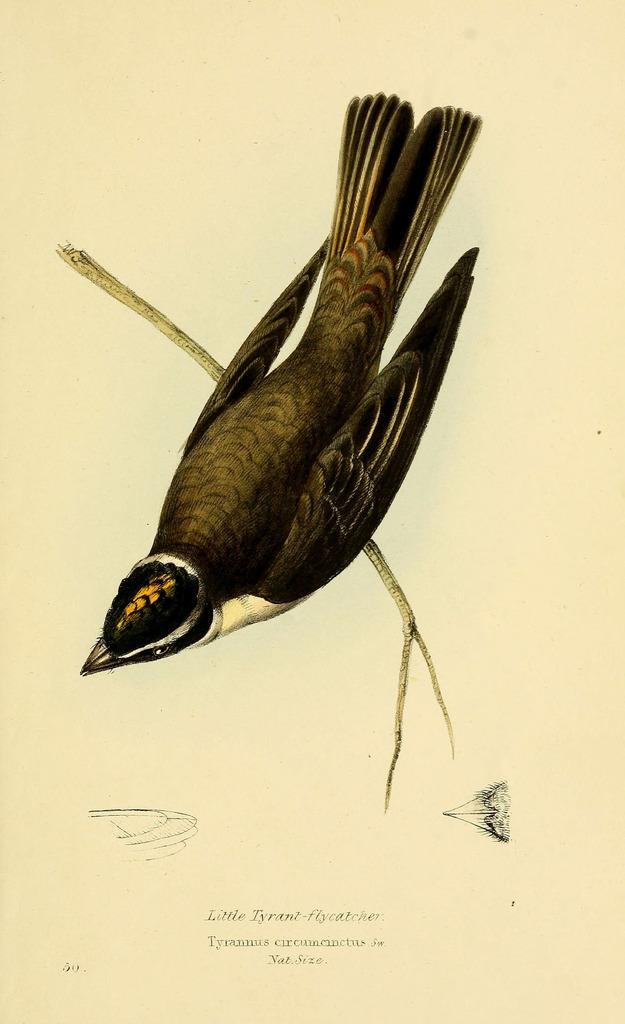Could you give a brief overview of what you see in this image? In this image I can see a drawing of a bird which is sitting on a branch of a tree. 